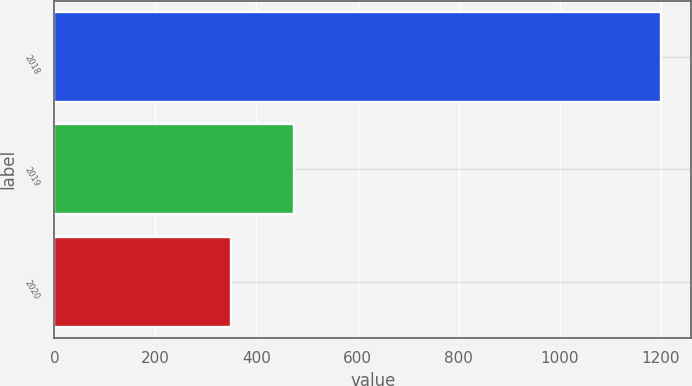Convert chart to OTSL. <chart><loc_0><loc_0><loc_500><loc_500><bar_chart><fcel>2018<fcel>2019<fcel>2020<nl><fcel>1200<fcel>475<fcel>350<nl></chart> 